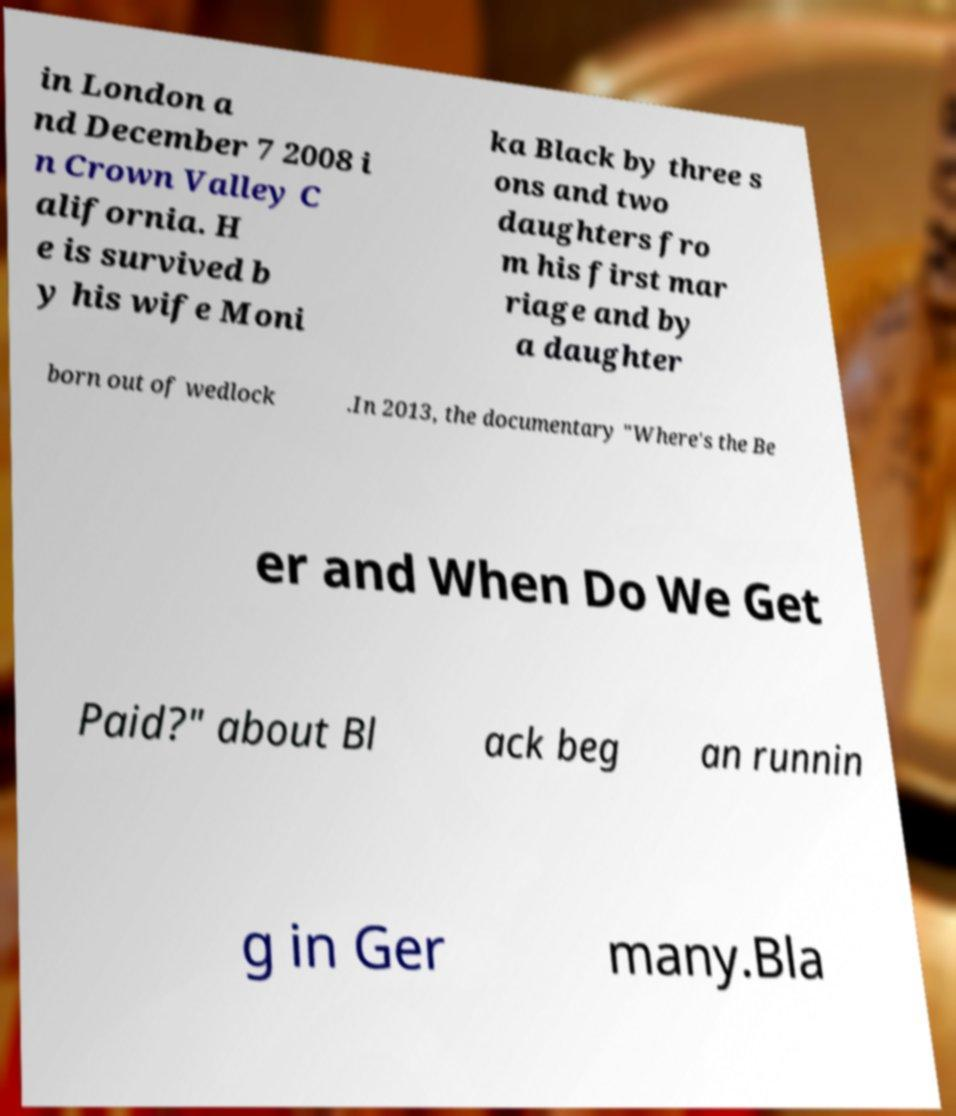There's text embedded in this image that I need extracted. Can you transcribe it verbatim? in London a nd December 7 2008 i n Crown Valley C alifornia. H e is survived b y his wife Moni ka Black by three s ons and two daughters fro m his first mar riage and by a daughter born out of wedlock .In 2013, the documentary "Where's the Be er and When Do We Get Paid?" about Bl ack beg an runnin g in Ger many.Bla 